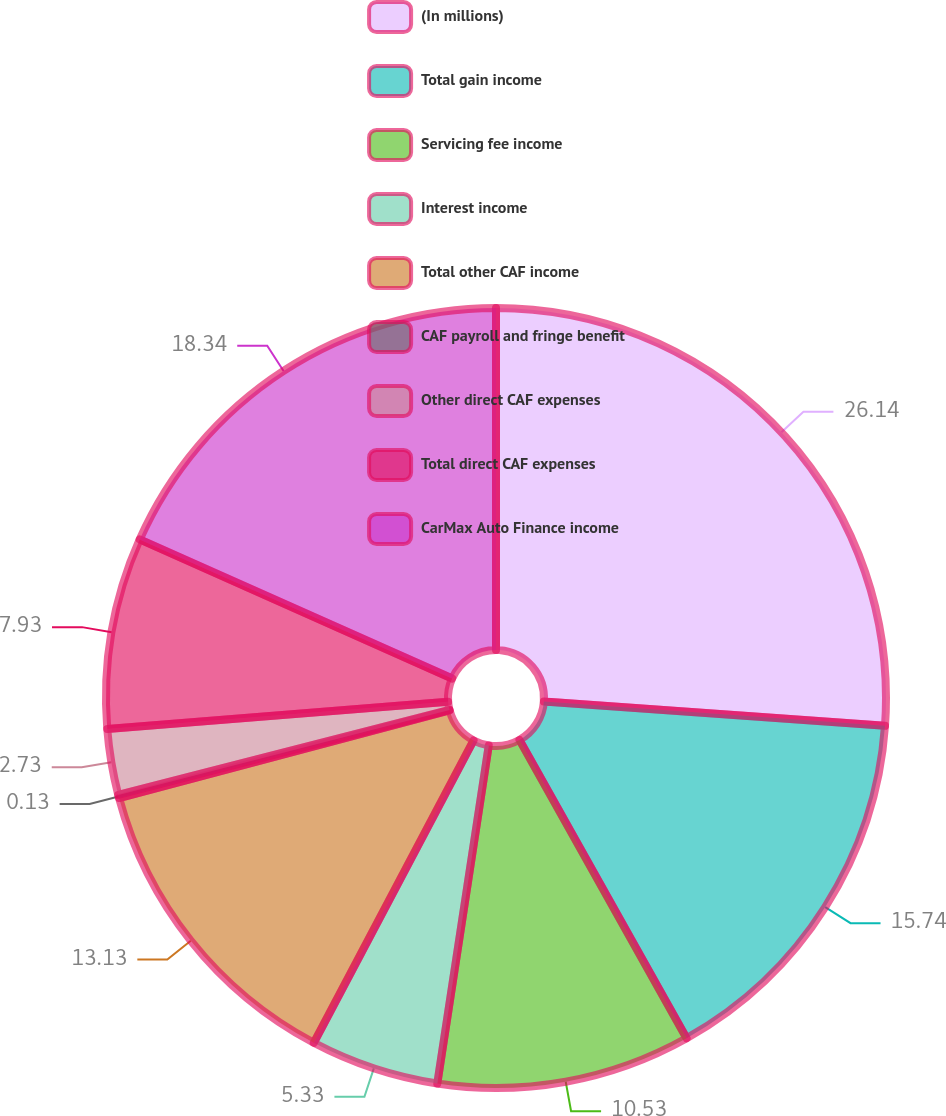Convert chart to OTSL. <chart><loc_0><loc_0><loc_500><loc_500><pie_chart><fcel>(In millions)<fcel>Total gain income<fcel>Servicing fee income<fcel>Interest income<fcel>Total other CAF income<fcel>CAF payroll and fringe benefit<fcel>Other direct CAF expenses<fcel>Total direct CAF expenses<fcel>CarMax Auto Finance income<nl><fcel>26.13%<fcel>15.73%<fcel>10.53%<fcel>5.33%<fcel>13.13%<fcel>0.13%<fcel>2.73%<fcel>7.93%<fcel>18.33%<nl></chart> 